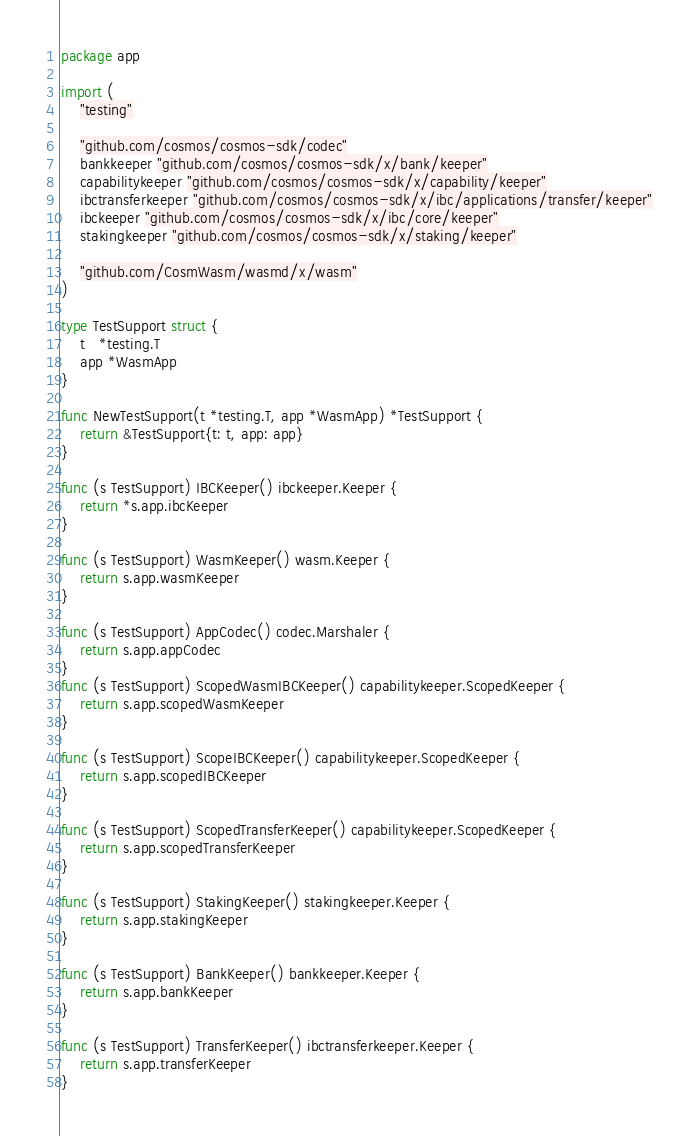Convert code to text. <code><loc_0><loc_0><loc_500><loc_500><_Go_>package app

import (
	"testing"

	"github.com/cosmos/cosmos-sdk/codec"
	bankkeeper "github.com/cosmos/cosmos-sdk/x/bank/keeper"
	capabilitykeeper "github.com/cosmos/cosmos-sdk/x/capability/keeper"
	ibctransferkeeper "github.com/cosmos/cosmos-sdk/x/ibc/applications/transfer/keeper"
	ibckeeper "github.com/cosmos/cosmos-sdk/x/ibc/core/keeper"
	stakingkeeper "github.com/cosmos/cosmos-sdk/x/staking/keeper"

	"github.com/CosmWasm/wasmd/x/wasm"
)

type TestSupport struct {
	t   *testing.T
	app *WasmApp
}

func NewTestSupport(t *testing.T, app *WasmApp) *TestSupport {
	return &TestSupport{t: t, app: app}
}

func (s TestSupport) IBCKeeper() ibckeeper.Keeper {
	return *s.app.ibcKeeper
}

func (s TestSupport) WasmKeeper() wasm.Keeper {
	return s.app.wasmKeeper
}

func (s TestSupport) AppCodec() codec.Marshaler {
	return s.app.appCodec
}
func (s TestSupport) ScopedWasmIBCKeeper() capabilitykeeper.ScopedKeeper {
	return s.app.scopedWasmKeeper
}

func (s TestSupport) ScopeIBCKeeper() capabilitykeeper.ScopedKeeper {
	return s.app.scopedIBCKeeper
}

func (s TestSupport) ScopedTransferKeeper() capabilitykeeper.ScopedKeeper {
	return s.app.scopedTransferKeeper
}

func (s TestSupport) StakingKeeper() stakingkeeper.Keeper {
	return s.app.stakingKeeper
}

func (s TestSupport) BankKeeper() bankkeeper.Keeper {
	return s.app.bankKeeper
}

func (s TestSupport) TransferKeeper() ibctransferkeeper.Keeper {
	return s.app.transferKeeper
}
</code> 